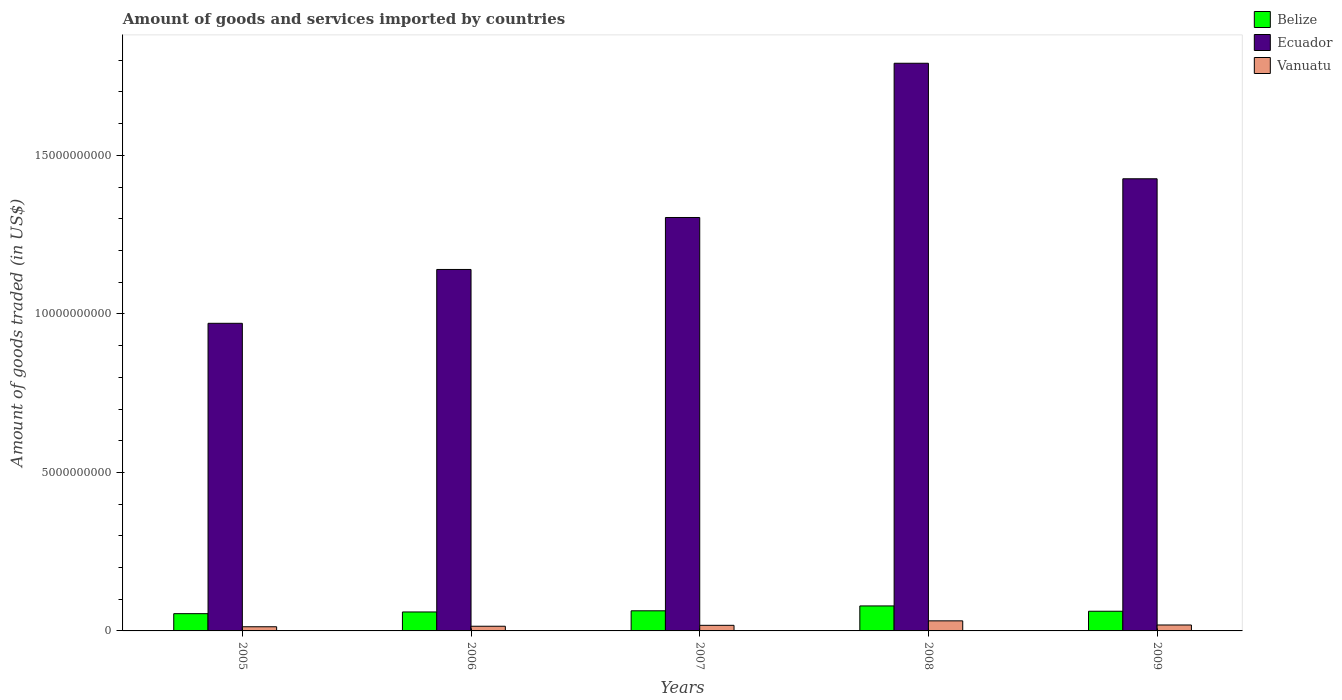How many different coloured bars are there?
Your answer should be compact. 3. Are the number of bars on each tick of the X-axis equal?
Offer a terse response. Yes. What is the label of the 1st group of bars from the left?
Your answer should be compact. 2005. What is the total amount of goods and services imported in Belize in 2008?
Ensure brevity in your answer.  7.88e+08. Across all years, what is the maximum total amount of goods and services imported in Belize?
Provide a short and direct response. 7.88e+08. Across all years, what is the minimum total amount of goods and services imported in Belize?
Give a very brief answer. 5.44e+08. In which year was the total amount of goods and services imported in Belize maximum?
Keep it short and to the point. 2008. In which year was the total amount of goods and services imported in Vanuatu minimum?
Ensure brevity in your answer.  2005. What is the total total amount of goods and services imported in Belize in the graph?
Your answer should be compact. 3.19e+09. What is the difference between the total amount of goods and services imported in Belize in 2007 and that in 2008?
Keep it short and to the point. -1.54e+08. What is the difference between the total amount of goods and services imported in Belize in 2005 and the total amount of goods and services imported in Vanuatu in 2009?
Your answer should be compact. 3.57e+08. What is the average total amount of goods and services imported in Belize per year?
Make the answer very short. 6.37e+08. In the year 2007, what is the difference between the total amount of goods and services imported in Ecuador and total amount of goods and services imported in Belize?
Make the answer very short. 1.24e+1. What is the ratio of the total amount of goods and services imported in Ecuador in 2005 to that in 2008?
Provide a short and direct response. 0.54. Is the total amount of goods and services imported in Belize in 2005 less than that in 2008?
Offer a terse response. Yes. Is the difference between the total amount of goods and services imported in Ecuador in 2007 and 2008 greater than the difference between the total amount of goods and services imported in Belize in 2007 and 2008?
Your response must be concise. No. What is the difference between the highest and the second highest total amount of goods and services imported in Vanuatu?
Provide a succinct answer. 1.31e+08. What is the difference between the highest and the lowest total amount of goods and services imported in Ecuador?
Offer a terse response. 8.20e+09. In how many years, is the total amount of goods and services imported in Belize greater than the average total amount of goods and services imported in Belize taken over all years?
Make the answer very short. 1. What does the 3rd bar from the left in 2009 represents?
Offer a very short reply. Vanuatu. What does the 3rd bar from the right in 2008 represents?
Keep it short and to the point. Belize. Is it the case that in every year, the sum of the total amount of goods and services imported in Vanuatu and total amount of goods and services imported in Belize is greater than the total amount of goods and services imported in Ecuador?
Your response must be concise. No. How many bars are there?
Ensure brevity in your answer.  15. How many years are there in the graph?
Provide a succinct answer. 5. Are the values on the major ticks of Y-axis written in scientific E-notation?
Offer a terse response. No. How are the legend labels stacked?
Provide a short and direct response. Vertical. What is the title of the graph?
Your response must be concise. Amount of goods and services imported by countries. What is the label or title of the Y-axis?
Provide a succinct answer. Amount of goods traded (in US$). What is the Amount of goods traded (in US$) of Belize in 2005?
Provide a short and direct response. 5.44e+08. What is the Amount of goods traded (in US$) in Ecuador in 2005?
Provide a succinct answer. 9.70e+09. What is the Amount of goods traded (in US$) in Vanuatu in 2005?
Provide a succinct answer. 1.31e+08. What is the Amount of goods traded (in US$) of Belize in 2006?
Offer a very short reply. 5.98e+08. What is the Amount of goods traded (in US$) of Ecuador in 2006?
Provide a succinct answer. 1.14e+1. What is the Amount of goods traded (in US$) of Vanuatu in 2006?
Keep it short and to the point. 1.48e+08. What is the Amount of goods traded (in US$) in Belize in 2007?
Offer a very short reply. 6.35e+08. What is the Amount of goods traded (in US$) in Ecuador in 2007?
Your answer should be very brief. 1.30e+1. What is the Amount of goods traded (in US$) in Vanuatu in 2007?
Your answer should be compact. 1.76e+08. What is the Amount of goods traded (in US$) in Belize in 2008?
Provide a short and direct response. 7.88e+08. What is the Amount of goods traded (in US$) of Ecuador in 2008?
Offer a terse response. 1.79e+1. What is the Amount of goods traded (in US$) of Vanuatu in 2008?
Offer a very short reply. 3.18e+08. What is the Amount of goods traded (in US$) in Belize in 2009?
Make the answer very short. 6.21e+08. What is the Amount of goods traded (in US$) of Ecuador in 2009?
Your answer should be very brief. 1.43e+1. What is the Amount of goods traded (in US$) of Vanuatu in 2009?
Your answer should be compact. 1.87e+08. Across all years, what is the maximum Amount of goods traded (in US$) of Belize?
Give a very brief answer. 7.88e+08. Across all years, what is the maximum Amount of goods traded (in US$) in Ecuador?
Offer a very short reply. 1.79e+1. Across all years, what is the maximum Amount of goods traded (in US$) of Vanuatu?
Provide a succinct answer. 3.18e+08. Across all years, what is the minimum Amount of goods traded (in US$) in Belize?
Keep it short and to the point. 5.44e+08. Across all years, what is the minimum Amount of goods traded (in US$) of Ecuador?
Your answer should be compact. 9.70e+09. Across all years, what is the minimum Amount of goods traded (in US$) in Vanuatu?
Offer a very short reply. 1.31e+08. What is the total Amount of goods traded (in US$) of Belize in the graph?
Keep it short and to the point. 3.19e+09. What is the total Amount of goods traded (in US$) of Ecuador in the graph?
Your response must be concise. 6.63e+1. What is the total Amount of goods traded (in US$) in Vanuatu in the graph?
Ensure brevity in your answer.  9.60e+08. What is the difference between the Amount of goods traded (in US$) of Belize in 2005 and that in 2006?
Your answer should be compact. -5.37e+07. What is the difference between the Amount of goods traded (in US$) of Ecuador in 2005 and that in 2006?
Offer a terse response. -1.70e+09. What is the difference between the Amount of goods traded (in US$) of Vanuatu in 2005 and that in 2006?
Provide a succinct answer. -1.64e+07. What is the difference between the Amount of goods traded (in US$) of Belize in 2005 and that in 2007?
Provide a short and direct response. -9.05e+07. What is the difference between the Amount of goods traded (in US$) of Ecuador in 2005 and that in 2007?
Provide a succinct answer. -3.34e+09. What is the difference between the Amount of goods traded (in US$) of Vanuatu in 2005 and that in 2007?
Your answer should be very brief. -4.53e+07. What is the difference between the Amount of goods traded (in US$) of Belize in 2005 and that in 2008?
Ensure brevity in your answer.  -2.44e+08. What is the difference between the Amount of goods traded (in US$) of Ecuador in 2005 and that in 2008?
Your response must be concise. -8.20e+09. What is the difference between the Amount of goods traded (in US$) in Vanuatu in 2005 and that in 2008?
Your answer should be very brief. -1.87e+08. What is the difference between the Amount of goods traded (in US$) in Belize in 2005 and that in 2009?
Ensure brevity in your answer.  -7.63e+07. What is the difference between the Amount of goods traded (in US$) in Ecuador in 2005 and that in 2009?
Give a very brief answer. -4.56e+09. What is the difference between the Amount of goods traded (in US$) in Vanuatu in 2005 and that in 2009?
Make the answer very short. -5.60e+07. What is the difference between the Amount of goods traded (in US$) of Belize in 2006 and that in 2007?
Provide a short and direct response. -3.68e+07. What is the difference between the Amount of goods traded (in US$) of Ecuador in 2006 and that in 2007?
Provide a succinct answer. -1.64e+09. What is the difference between the Amount of goods traded (in US$) of Vanuatu in 2006 and that in 2007?
Your answer should be very brief. -2.89e+07. What is the difference between the Amount of goods traded (in US$) of Belize in 2006 and that in 2008?
Provide a short and direct response. -1.90e+08. What is the difference between the Amount of goods traded (in US$) in Ecuador in 2006 and that in 2008?
Provide a succinct answer. -6.50e+09. What is the difference between the Amount of goods traded (in US$) of Vanuatu in 2006 and that in 2008?
Ensure brevity in your answer.  -1.70e+08. What is the difference between the Amount of goods traded (in US$) of Belize in 2006 and that in 2009?
Offer a terse response. -2.26e+07. What is the difference between the Amount of goods traded (in US$) of Ecuador in 2006 and that in 2009?
Your response must be concise. -2.86e+09. What is the difference between the Amount of goods traded (in US$) of Vanuatu in 2006 and that in 2009?
Give a very brief answer. -3.96e+07. What is the difference between the Amount of goods traded (in US$) in Belize in 2007 and that in 2008?
Make the answer very short. -1.54e+08. What is the difference between the Amount of goods traded (in US$) of Ecuador in 2007 and that in 2008?
Offer a terse response. -4.86e+09. What is the difference between the Amount of goods traded (in US$) of Vanuatu in 2007 and that in 2008?
Offer a very short reply. -1.41e+08. What is the difference between the Amount of goods traded (in US$) in Belize in 2007 and that in 2009?
Your answer should be compact. 1.42e+07. What is the difference between the Amount of goods traded (in US$) of Ecuador in 2007 and that in 2009?
Your answer should be compact. -1.22e+09. What is the difference between the Amount of goods traded (in US$) of Vanuatu in 2007 and that in 2009?
Provide a short and direct response. -1.07e+07. What is the difference between the Amount of goods traded (in US$) of Belize in 2008 and that in 2009?
Provide a short and direct response. 1.68e+08. What is the difference between the Amount of goods traded (in US$) in Ecuador in 2008 and that in 2009?
Your response must be concise. 3.64e+09. What is the difference between the Amount of goods traded (in US$) in Vanuatu in 2008 and that in 2009?
Keep it short and to the point. 1.31e+08. What is the difference between the Amount of goods traded (in US$) of Belize in 2005 and the Amount of goods traded (in US$) of Ecuador in 2006?
Make the answer very short. -1.09e+1. What is the difference between the Amount of goods traded (in US$) in Belize in 2005 and the Amount of goods traded (in US$) in Vanuatu in 2006?
Your answer should be very brief. 3.97e+08. What is the difference between the Amount of goods traded (in US$) of Ecuador in 2005 and the Amount of goods traded (in US$) of Vanuatu in 2006?
Provide a succinct answer. 9.56e+09. What is the difference between the Amount of goods traded (in US$) in Belize in 2005 and the Amount of goods traded (in US$) in Ecuador in 2007?
Your answer should be compact. -1.25e+1. What is the difference between the Amount of goods traded (in US$) in Belize in 2005 and the Amount of goods traded (in US$) in Vanuatu in 2007?
Ensure brevity in your answer.  3.68e+08. What is the difference between the Amount of goods traded (in US$) of Ecuador in 2005 and the Amount of goods traded (in US$) of Vanuatu in 2007?
Ensure brevity in your answer.  9.53e+09. What is the difference between the Amount of goods traded (in US$) of Belize in 2005 and the Amount of goods traded (in US$) of Ecuador in 2008?
Give a very brief answer. -1.74e+1. What is the difference between the Amount of goods traded (in US$) of Belize in 2005 and the Amount of goods traded (in US$) of Vanuatu in 2008?
Your answer should be compact. 2.26e+08. What is the difference between the Amount of goods traded (in US$) of Ecuador in 2005 and the Amount of goods traded (in US$) of Vanuatu in 2008?
Keep it short and to the point. 9.39e+09. What is the difference between the Amount of goods traded (in US$) in Belize in 2005 and the Amount of goods traded (in US$) in Ecuador in 2009?
Provide a short and direct response. -1.37e+1. What is the difference between the Amount of goods traded (in US$) of Belize in 2005 and the Amount of goods traded (in US$) of Vanuatu in 2009?
Offer a very short reply. 3.57e+08. What is the difference between the Amount of goods traded (in US$) of Ecuador in 2005 and the Amount of goods traded (in US$) of Vanuatu in 2009?
Offer a very short reply. 9.52e+09. What is the difference between the Amount of goods traded (in US$) of Belize in 2006 and the Amount of goods traded (in US$) of Ecuador in 2007?
Offer a very short reply. -1.24e+1. What is the difference between the Amount of goods traded (in US$) of Belize in 2006 and the Amount of goods traded (in US$) of Vanuatu in 2007?
Your answer should be compact. 4.21e+08. What is the difference between the Amount of goods traded (in US$) of Ecuador in 2006 and the Amount of goods traded (in US$) of Vanuatu in 2007?
Provide a succinct answer. 1.12e+1. What is the difference between the Amount of goods traded (in US$) in Belize in 2006 and the Amount of goods traded (in US$) in Ecuador in 2008?
Your response must be concise. -1.73e+1. What is the difference between the Amount of goods traded (in US$) of Belize in 2006 and the Amount of goods traded (in US$) of Vanuatu in 2008?
Offer a very short reply. 2.80e+08. What is the difference between the Amount of goods traded (in US$) in Ecuador in 2006 and the Amount of goods traded (in US$) in Vanuatu in 2008?
Make the answer very short. 1.11e+1. What is the difference between the Amount of goods traded (in US$) of Belize in 2006 and the Amount of goods traded (in US$) of Ecuador in 2009?
Provide a short and direct response. -1.37e+1. What is the difference between the Amount of goods traded (in US$) in Belize in 2006 and the Amount of goods traded (in US$) in Vanuatu in 2009?
Your answer should be very brief. 4.11e+08. What is the difference between the Amount of goods traded (in US$) of Ecuador in 2006 and the Amount of goods traded (in US$) of Vanuatu in 2009?
Provide a short and direct response. 1.12e+1. What is the difference between the Amount of goods traded (in US$) of Belize in 2007 and the Amount of goods traded (in US$) of Ecuador in 2008?
Offer a very short reply. -1.73e+1. What is the difference between the Amount of goods traded (in US$) in Belize in 2007 and the Amount of goods traded (in US$) in Vanuatu in 2008?
Offer a very short reply. 3.17e+08. What is the difference between the Amount of goods traded (in US$) of Ecuador in 2007 and the Amount of goods traded (in US$) of Vanuatu in 2008?
Offer a terse response. 1.27e+1. What is the difference between the Amount of goods traded (in US$) of Belize in 2007 and the Amount of goods traded (in US$) of Ecuador in 2009?
Your answer should be compact. -1.36e+1. What is the difference between the Amount of goods traded (in US$) in Belize in 2007 and the Amount of goods traded (in US$) in Vanuatu in 2009?
Your response must be concise. 4.48e+08. What is the difference between the Amount of goods traded (in US$) in Ecuador in 2007 and the Amount of goods traded (in US$) in Vanuatu in 2009?
Your answer should be very brief. 1.29e+1. What is the difference between the Amount of goods traded (in US$) of Belize in 2008 and the Amount of goods traded (in US$) of Ecuador in 2009?
Ensure brevity in your answer.  -1.35e+1. What is the difference between the Amount of goods traded (in US$) of Belize in 2008 and the Amount of goods traded (in US$) of Vanuatu in 2009?
Offer a very short reply. 6.01e+08. What is the difference between the Amount of goods traded (in US$) in Ecuador in 2008 and the Amount of goods traded (in US$) in Vanuatu in 2009?
Your answer should be compact. 1.77e+1. What is the average Amount of goods traded (in US$) in Belize per year?
Your answer should be compact. 6.37e+08. What is the average Amount of goods traded (in US$) in Ecuador per year?
Your response must be concise. 1.33e+1. What is the average Amount of goods traded (in US$) in Vanuatu per year?
Your answer should be compact. 1.92e+08. In the year 2005, what is the difference between the Amount of goods traded (in US$) of Belize and Amount of goods traded (in US$) of Ecuador?
Provide a short and direct response. -9.16e+09. In the year 2005, what is the difference between the Amount of goods traded (in US$) in Belize and Amount of goods traded (in US$) in Vanuatu?
Offer a very short reply. 4.13e+08. In the year 2005, what is the difference between the Amount of goods traded (in US$) of Ecuador and Amount of goods traded (in US$) of Vanuatu?
Provide a succinct answer. 9.57e+09. In the year 2006, what is the difference between the Amount of goods traded (in US$) of Belize and Amount of goods traded (in US$) of Ecuador?
Provide a short and direct response. -1.08e+1. In the year 2006, what is the difference between the Amount of goods traded (in US$) in Belize and Amount of goods traded (in US$) in Vanuatu?
Provide a succinct answer. 4.50e+08. In the year 2006, what is the difference between the Amount of goods traded (in US$) in Ecuador and Amount of goods traded (in US$) in Vanuatu?
Make the answer very short. 1.13e+1. In the year 2007, what is the difference between the Amount of goods traded (in US$) of Belize and Amount of goods traded (in US$) of Ecuador?
Give a very brief answer. -1.24e+1. In the year 2007, what is the difference between the Amount of goods traded (in US$) in Belize and Amount of goods traded (in US$) in Vanuatu?
Provide a short and direct response. 4.58e+08. In the year 2007, what is the difference between the Amount of goods traded (in US$) in Ecuador and Amount of goods traded (in US$) in Vanuatu?
Offer a terse response. 1.29e+1. In the year 2008, what is the difference between the Amount of goods traded (in US$) of Belize and Amount of goods traded (in US$) of Ecuador?
Your response must be concise. -1.71e+1. In the year 2008, what is the difference between the Amount of goods traded (in US$) in Belize and Amount of goods traded (in US$) in Vanuatu?
Your response must be concise. 4.70e+08. In the year 2008, what is the difference between the Amount of goods traded (in US$) of Ecuador and Amount of goods traded (in US$) of Vanuatu?
Offer a terse response. 1.76e+1. In the year 2009, what is the difference between the Amount of goods traded (in US$) in Belize and Amount of goods traded (in US$) in Ecuador?
Ensure brevity in your answer.  -1.36e+1. In the year 2009, what is the difference between the Amount of goods traded (in US$) of Belize and Amount of goods traded (in US$) of Vanuatu?
Offer a very short reply. 4.33e+08. In the year 2009, what is the difference between the Amount of goods traded (in US$) of Ecuador and Amount of goods traded (in US$) of Vanuatu?
Your answer should be compact. 1.41e+1. What is the ratio of the Amount of goods traded (in US$) of Belize in 2005 to that in 2006?
Offer a very short reply. 0.91. What is the ratio of the Amount of goods traded (in US$) in Ecuador in 2005 to that in 2006?
Ensure brevity in your answer.  0.85. What is the ratio of the Amount of goods traded (in US$) in Vanuatu in 2005 to that in 2006?
Make the answer very short. 0.89. What is the ratio of the Amount of goods traded (in US$) in Belize in 2005 to that in 2007?
Provide a succinct answer. 0.86. What is the ratio of the Amount of goods traded (in US$) of Ecuador in 2005 to that in 2007?
Make the answer very short. 0.74. What is the ratio of the Amount of goods traded (in US$) in Vanuatu in 2005 to that in 2007?
Keep it short and to the point. 0.74. What is the ratio of the Amount of goods traded (in US$) of Belize in 2005 to that in 2008?
Offer a very short reply. 0.69. What is the ratio of the Amount of goods traded (in US$) in Ecuador in 2005 to that in 2008?
Give a very brief answer. 0.54. What is the ratio of the Amount of goods traded (in US$) in Vanuatu in 2005 to that in 2008?
Your response must be concise. 0.41. What is the ratio of the Amount of goods traded (in US$) of Belize in 2005 to that in 2009?
Make the answer very short. 0.88. What is the ratio of the Amount of goods traded (in US$) in Ecuador in 2005 to that in 2009?
Ensure brevity in your answer.  0.68. What is the ratio of the Amount of goods traded (in US$) in Vanuatu in 2005 to that in 2009?
Keep it short and to the point. 0.7. What is the ratio of the Amount of goods traded (in US$) of Belize in 2006 to that in 2007?
Your answer should be compact. 0.94. What is the ratio of the Amount of goods traded (in US$) of Ecuador in 2006 to that in 2007?
Offer a very short reply. 0.87. What is the ratio of the Amount of goods traded (in US$) of Vanuatu in 2006 to that in 2007?
Your response must be concise. 0.84. What is the ratio of the Amount of goods traded (in US$) in Belize in 2006 to that in 2008?
Offer a terse response. 0.76. What is the ratio of the Amount of goods traded (in US$) of Ecuador in 2006 to that in 2008?
Give a very brief answer. 0.64. What is the ratio of the Amount of goods traded (in US$) in Vanuatu in 2006 to that in 2008?
Your answer should be compact. 0.46. What is the ratio of the Amount of goods traded (in US$) of Belize in 2006 to that in 2009?
Make the answer very short. 0.96. What is the ratio of the Amount of goods traded (in US$) in Ecuador in 2006 to that in 2009?
Make the answer very short. 0.8. What is the ratio of the Amount of goods traded (in US$) of Vanuatu in 2006 to that in 2009?
Keep it short and to the point. 0.79. What is the ratio of the Amount of goods traded (in US$) of Belize in 2007 to that in 2008?
Make the answer very short. 0.81. What is the ratio of the Amount of goods traded (in US$) of Ecuador in 2007 to that in 2008?
Offer a terse response. 0.73. What is the ratio of the Amount of goods traded (in US$) of Vanuatu in 2007 to that in 2008?
Offer a very short reply. 0.56. What is the ratio of the Amount of goods traded (in US$) in Belize in 2007 to that in 2009?
Make the answer very short. 1.02. What is the ratio of the Amount of goods traded (in US$) of Ecuador in 2007 to that in 2009?
Your answer should be compact. 0.91. What is the ratio of the Amount of goods traded (in US$) in Vanuatu in 2007 to that in 2009?
Give a very brief answer. 0.94. What is the ratio of the Amount of goods traded (in US$) of Belize in 2008 to that in 2009?
Offer a terse response. 1.27. What is the ratio of the Amount of goods traded (in US$) of Ecuador in 2008 to that in 2009?
Keep it short and to the point. 1.26. What is the ratio of the Amount of goods traded (in US$) in Vanuatu in 2008 to that in 2009?
Provide a short and direct response. 1.7. What is the difference between the highest and the second highest Amount of goods traded (in US$) of Belize?
Offer a very short reply. 1.54e+08. What is the difference between the highest and the second highest Amount of goods traded (in US$) in Ecuador?
Your response must be concise. 3.64e+09. What is the difference between the highest and the second highest Amount of goods traded (in US$) in Vanuatu?
Your response must be concise. 1.31e+08. What is the difference between the highest and the lowest Amount of goods traded (in US$) of Belize?
Give a very brief answer. 2.44e+08. What is the difference between the highest and the lowest Amount of goods traded (in US$) of Ecuador?
Make the answer very short. 8.20e+09. What is the difference between the highest and the lowest Amount of goods traded (in US$) in Vanuatu?
Give a very brief answer. 1.87e+08. 